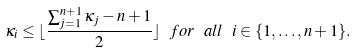<formula> <loc_0><loc_0><loc_500><loc_500>\kappa _ { i } \leq \lfloor \frac { \sum _ { j = 1 } ^ { n + 1 } \kappa _ { j } - n + 1 } { 2 } \rfloor \ f o r \ a l l \ i \in \{ 1 , \dots , n + 1 \} .</formula> 